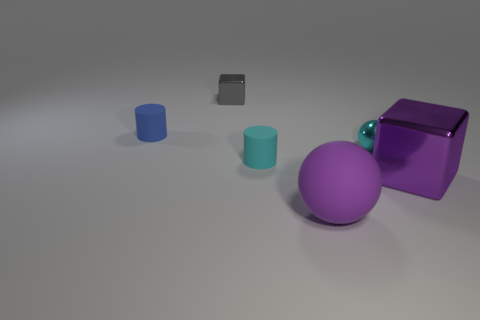Add 4 red shiny balls. How many objects exist? 10 Subtract all cubes. How many objects are left? 4 Add 4 tiny cyan metal things. How many tiny cyan metal things are left? 5 Add 3 big gray metallic things. How many big gray metallic things exist? 3 Subtract 0 brown cubes. How many objects are left? 6 Subtract all big brown cylinders. Subtract all gray cubes. How many objects are left? 5 